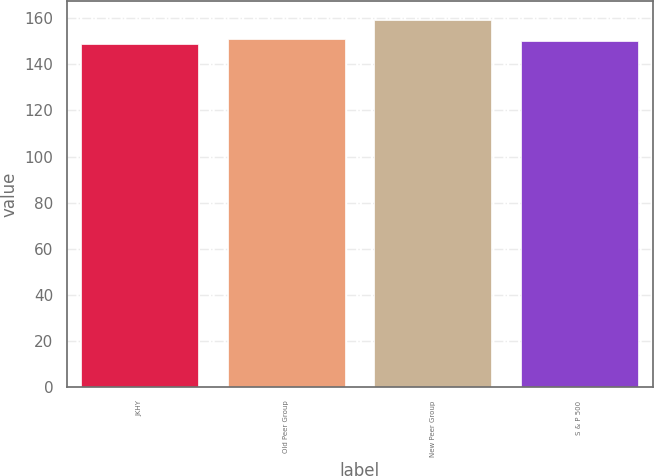Convert chart to OTSL. <chart><loc_0><loc_0><loc_500><loc_500><bar_chart><fcel>JKHY<fcel>Old Peer Group<fcel>New Peer Group<fcel>S & P 500<nl><fcel>148.92<fcel>151<fcel>159.31<fcel>149.96<nl></chart> 